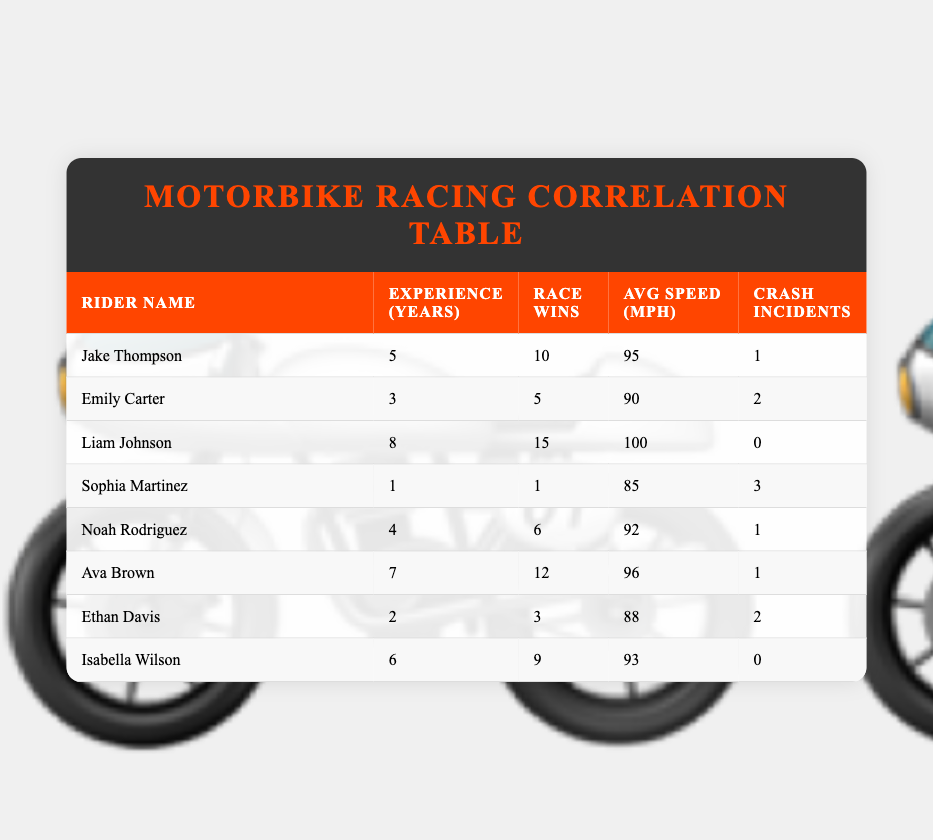What is the average number of race wins among the riders? We sum the race wins: (10 + 5 + 15 + 1 + 6 + 12 + 3 + 9) = 61. With 8 riders, the average wins is 61 / 8 = 7.625.
Answer: 7.625 Which rider has the highest average speed? To find the highest average speed, we look at the average speed column. Liam Johnson has the highest average speed at 100 mph.
Answer: Liam Johnson Is it true that Emily Carter has more race wins than Sophia Martinez? Emily Carter has 5 race wins while Sophia Martinez has only 1. Since 5 is greater than 1, the statement is true.
Answer: Yes What is the total number of crash incidents for all riders? We sum the crash incidents: (1 + 2 + 0 + 3 + 1 + 1 + 2 + 0) = 10.
Answer: 10 How many riders have 6 or more race wins? The riders with 6 or more race wins are Jake Thompson (10), Liam Johnson (15), Ava Brown (12), and Isabella Wilson (9). This totals 4 riders.
Answer: 4 What is the difference in the number of race wins between the rider with the most wins and the rider with the least wins? The most wins are by Liam Johnson with 15 and the least wins by Sophia Martinez with 1. The difference is 15 - 1 = 14.
Answer: 14 Which rider has both the most race wins and the least crash incidents? Liam Johnson has the most race wins (15) and also has the least crash incidents (0).
Answer: Liam Johnson Is the average speed of Ava Brown greater than that of Ethan Davis? Ava Brown has an average speed of 96 mph while Ethan Davis has 88 mph. Since 96 is greater than 88, the statement is true.
Answer: Yes 